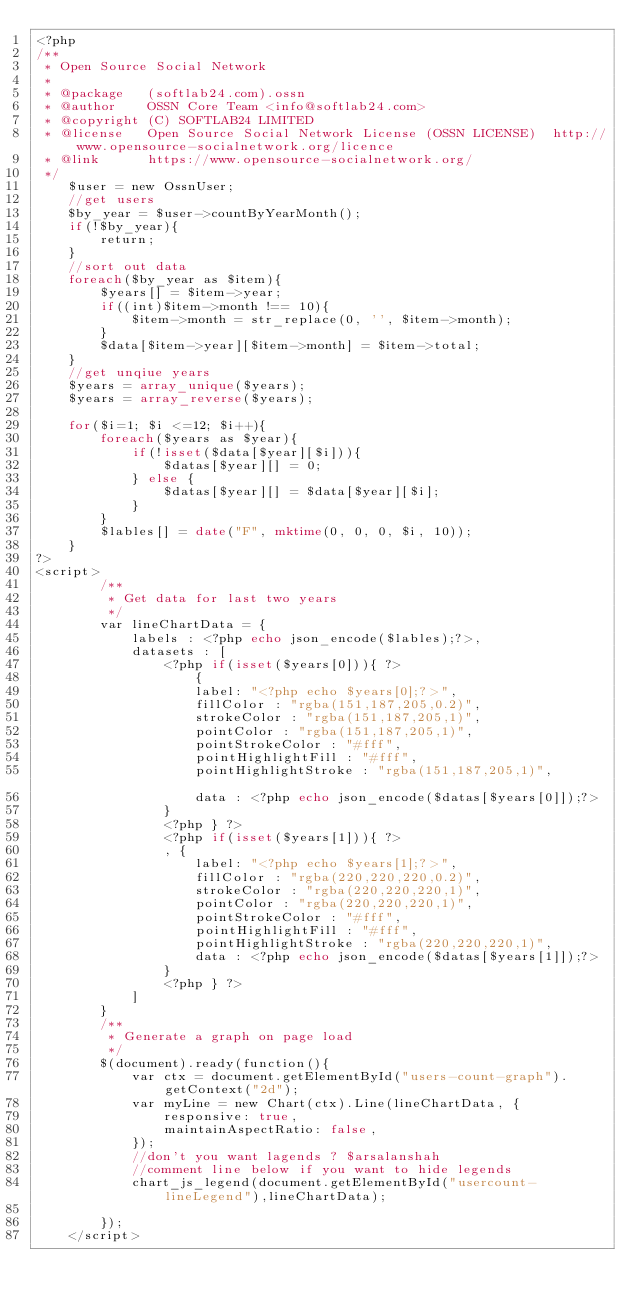<code> <loc_0><loc_0><loc_500><loc_500><_PHP_><?php
/**
 * Open Source Social Network
 *
 * @package   (softlab24.com).ossn
 * @author    OSSN Core Team <info@softlab24.com>
 * @copyright (C) SOFTLAB24 LIMITED
 * @license   Open Source Social Network License (OSSN LICENSE)  http://www.opensource-socialnetwork.org/licence
 * @link      https://www.opensource-socialnetwork.org/
 */
	$user = new OssnUser;
	//get users
	$by_year = $user->countByYearMonth();
	if(!$by_year){
		return;
	}
	//sort out data
	foreach($by_year as $item){
		$years[] = $item->year;
		if((int)$item->month !== 10){
			$item->month = str_replace(0, '', $item->month);
		}
		$data[$item->year][$item->month] = $item->total;
	}	
	//get unqiue years
	$years = array_unique($years);
	$years = array_reverse($years);

	for($i=1; $i <=12; $i++){
		foreach($years as $year){
			if(!isset($data[$year][$i])){
				$datas[$year][] = 0;
			} else {
				$datas[$year][] = $data[$year][$i];
			}
		}
		$lables[] = date("F", mktime(0, 0, 0, $i, 10));
	}
?>
<script>
		/**
		 * Get data for last two years
		 */
		var lineChartData = {
			labels : <?php echo json_encode($lables);?>,
			datasets : [
				<?php if(isset($years[0])){ ?>
					{
					label: "<?php echo $years[0];?>",
					fillColor : "rgba(151,187,205,0.2)",
					strokeColor : "rgba(151,187,205,1)",
					pointColor : "rgba(151,187,205,1)",
					pointStrokeColor : "#fff",
					pointHighlightFill : "#fff",
					pointHighlightStroke : "rgba(151,187,205,1)",					
					data : <?php echo json_encode($datas[$years[0]]);?>
				}	
				<?php } ?>
				<?php if(isset($years[1])){ ?>
				, {
					label: "<?php echo $years[1];?>",
					fillColor : "rgba(220,220,220,0.2)",
					strokeColor : "rgba(220,220,220,1)",
					pointColor : "rgba(220,220,220,1)",
					pointStrokeColor : "#fff",
					pointHighlightFill : "#fff",
					pointHighlightStroke : "rgba(220,220,220,1)",
					data : <?php echo json_encode($datas[$years[1]]);?>
				}	
				<?php } ?>
			]
		}
		/**
		 * Generate a graph on page load
		 */		
		$(document).ready(function(){
			var ctx = document.getElementById("users-count-graph").getContext("2d");
			var myLine = new Chart(ctx).Line(lineChartData, {
				responsive: true,
				maintainAspectRatio: false,
			});
			//don't you want lagends ? $arsalanshah
			//comment line below if you want to hide legends
			chart_js_legend(document.getElementById("usercount-lineLegend"),lineChartData);

		});
	</script></code> 